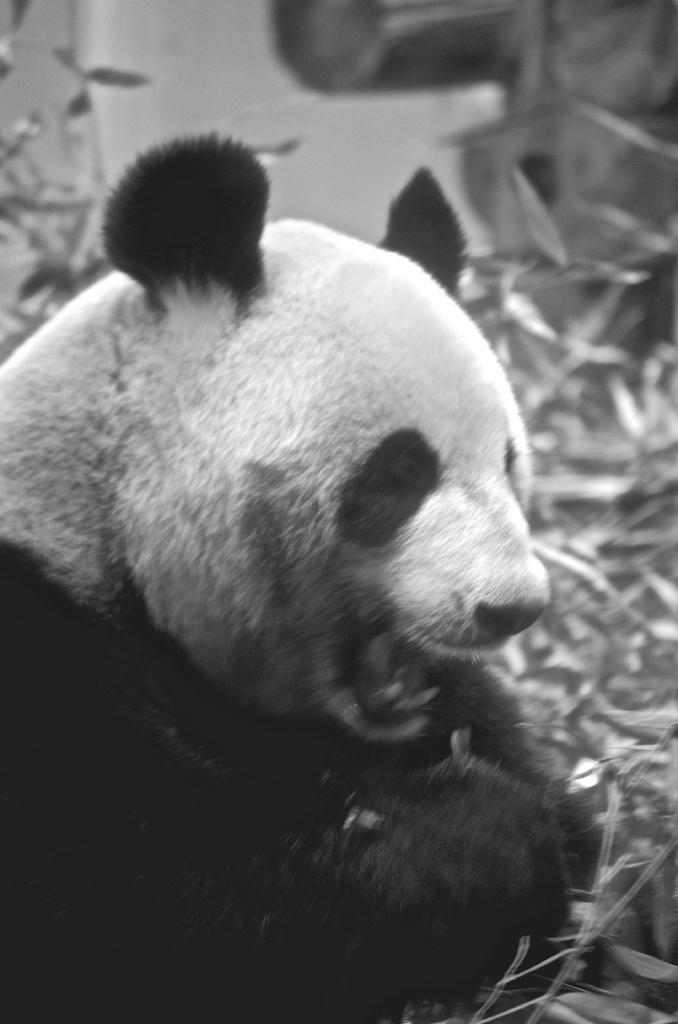What is the color scheme of the image? The image is black and white. What animal is present in the image? There is a panda in the image. What type of vegetation can be seen in the image? Plants and grass are visible in the image. How would you describe the background of the image? The background of the image is blurred. Where might this image have been taken? The image might have been taken in a zoo. What type of leather is visible in the image? There is no leather present in the image. Does the existence of the panda in the image prove the existence of other mythical creatures? The presence of a panda in the image does not prove the existence of other mythical creatures, as pandas are real animals. Can you tell me the name of the judge who presided over the panda's case in the image? There is no judge or legal case involving the panda in the image. 